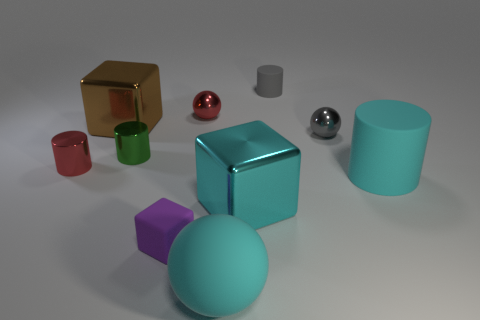What is the size of the brown object?
Give a very brief answer. Large. Are there the same number of gray shiny spheres that are in front of the rubber ball and red things?
Ensure brevity in your answer.  No. How many other things are the same color as the large matte cylinder?
Offer a very short reply. 2. What is the color of the matte object that is both to the right of the large cyan ball and to the left of the cyan cylinder?
Keep it short and to the point. Gray. There is a matte cylinder that is in front of the rubber thing behind the red shiny thing to the right of the big brown shiny thing; what is its size?
Your answer should be compact. Large. How many objects are either red objects that are behind the tiny gray metal object or large cyan objects in front of the cyan matte cylinder?
Offer a terse response. 3. What is the shape of the green metallic thing?
Ensure brevity in your answer.  Cylinder. How many other things are the same material as the big cylinder?
Your answer should be very brief. 3. What is the size of the purple matte object that is the same shape as the large brown thing?
Keep it short and to the point. Small. What is the material of the sphere to the right of the small matte thing on the right side of the rubber object in front of the small rubber block?
Your answer should be compact. Metal. 